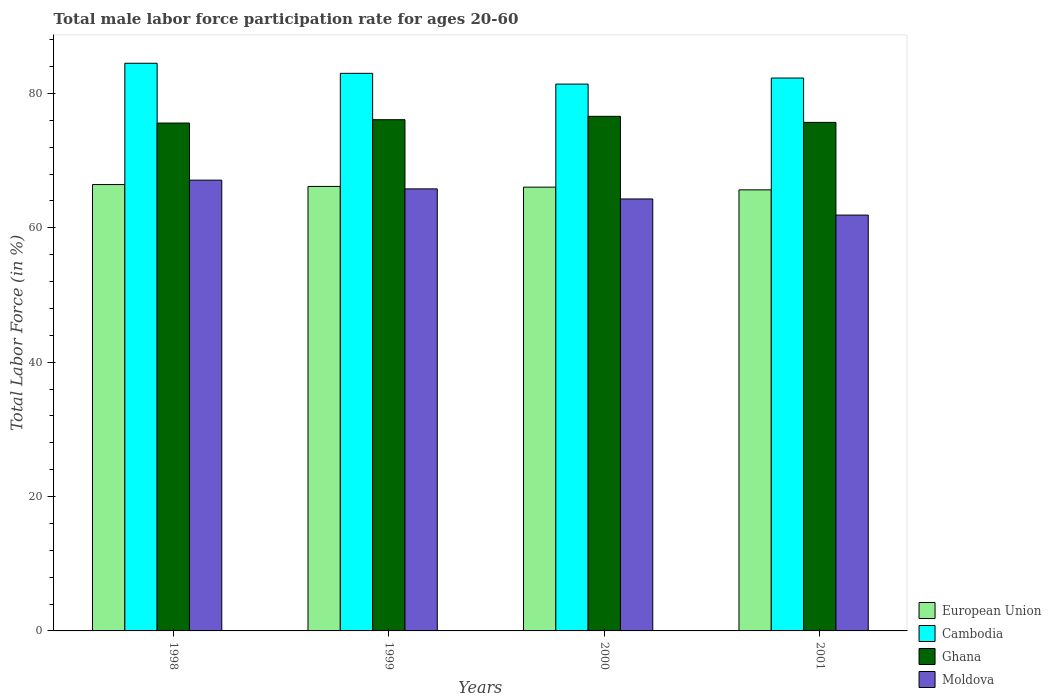How many different coloured bars are there?
Your answer should be compact. 4. Are the number of bars per tick equal to the number of legend labels?
Give a very brief answer. Yes. How many bars are there on the 3rd tick from the left?
Offer a very short reply. 4. How many bars are there on the 1st tick from the right?
Your response must be concise. 4. In how many cases, is the number of bars for a given year not equal to the number of legend labels?
Your answer should be very brief. 0. What is the male labor force participation rate in Moldova in 1998?
Your answer should be compact. 67.1. Across all years, what is the maximum male labor force participation rate in Cambodia?
Offer a very short reply. 84.5. Across all years, what is the minimum male labor force participation rate in Cambodia?
Make the answer very short. 81.4. In which year was the male labor force participation rate in Moldova maximum?
Offer a very short reply. 1998. In which year was the male labor force participation rate in Ghana minimum?
Provide a succinct answer. 1998. What is the total male labor force participation rate in Cambodia in the graph?
Provide a succinct answer. 331.2. What is the difference between the male labor force participation rate in Cambodia in 1998 and that in 2001?
Your response must be concise. 2.2. What is the difference between the male labor force participation rate in Moldova in 2000 and the male labor force participation rate in Ghana in 1998?
Your response must be concise. -11.3. What is the average male labor force participation rate in Cambodia per year?
Make the answer very short. 82.8. In the year 2000, what is the difference between the male labor force participation rate in Moldova and male labor force participation rate in Ghana?
Your answer should be very brief. -12.3. What is the ratio of the male labor force participation rate in Cambodia in 1999 to that in 2000?
Make the answer very short. 1.02. Is the difference between the male labor force participation rate in Moldova in 1998 and 1999 greater than the difference between the male labor force participation rate in Ghana in 1998 and 1999?
Your response must be concise. Yes. What is the difference between the highest and the second highest male labor force participation rate in Cambodia?
Ensure brevity in your answer.  1.5. What is the difference between the highest and the lowest male labor force participation rate in Cambodia?
Make the answer very short. 3.1. In how many years, is the male labor force participation rate in Moldova greater than the average male labor force participation rate in Moldova taken over all years?
Your answer should be compact. 2. What does the 2nd bar from the left in 1999 represents?
Provide a short and direct response. Cambodia. What does the 2nd bar from the right in 1999 represents?
Offer a very short reply. Ghana. Is it the case that in every year, the sum of the male labor force participation rate in European Union and male labor force participation rate in Ghana is greater than the male labor force participation rate in Moldova?
Your response must be concise. Yes. How many bars are there?
Make the answer very short. 16. Are all the bars in the graph horizontal?
Your answer should be very brief. No. How many years are there in the graph?
Your response must be concise. 4. What is the difference between two consecutive major ticks on the Y-axis?
Your answer should be very brief. 20. Does the graph contain grids?
Your answer should be compact. No. Where does the legend appear in the graph?
Your answer should be compact. Bottom right. How many legend labels are there?
Keep it short and to the point. 4. How are the legend labels stacked?
Your answer should be compact. Vertical. What is the title of the graph?
Your response must be concise. Total male labor force participation rate for ages 20-60. Does "Upper middle income" appear as one of the legend labels in the graph?
Your answer should be compact. No. What is the label or title of the Y-axis?
Give a very brief answer. Total Labor Force (in %). What is the Total Labor Force (in %) in European Union in 1998?
Provide a short and direct response. 66.44. What is the Total Labor Force (in %) of Cambodia in 1998?
Your answer should be very brief. 84.5. What is the Total Labor Force (in %) in Ghana in 1998?
Ensure brevity in your answer.  75.6. What is the Total Labor Force (in %) in Moldova in 1998?
Provide a short and direct response. 67.1. What is the Total Labor Force (in %) in European Union in 1999?
Provide a succinct answer. 66.16. What is the Total Labor Force (in %) of Ghana in 1999?
Your answer should be very brief. 76.1. What is the Total Labor Force (in %) of Moldova in 1999?
Offer a very short reply. 65.8. What is the Total Labor Force (in %) of European Union in 2000?
Keep it short and to the point. 66.06. What is the Total Labor Force (in %) in Cambodia in 2000?
Keep it short and to the point. 81.4. What is the Total Labor Force (in %) of Ghana in 2000?
Keep it short and to the point. 76.6. What is the Total Labor Force (in %) in Moldova in 2000?
Your answer should be very brief. 64.3. What is the Total Labor Force (in %) of European Union in 2001?
Your answer should be very brief. 65.66. What is the Total Labor Force (in %) in Cambodia in 2001?
Your response must be concise. 82.3. What is the Total Labor Force (in %) in Ghana in 2001?
Keep it short and to the point. 75.7. What is the Total Labor Force (in %) of Moldova in 2001?
Your answer should be compact. 61.9. Across all years, what is the maximum Total Labor Force (in %) of European Union?
Ensure brevity in your answer.  66.44. Across all years, what is the maximum Total Labor Force (in %) of Cambodia?
Provide a succinct answer. 84.5. Across all years, what is the maximum Total Labor Force (in %) in Ghana?
Provide a succinct answer. 76.6. Across all years, what is the maximum Total Labor Force (in %) of Moldova?
Ensure brevity in your answer.  67.1. Across all years, what is the minimum Total Labor Force (in %) in European Union?
Your response must be concise. 65.66. Across all years, what is the minimum Total Labor Force (in %) in Cambodia?
Offer a terse response. 81.4. Across all years, what is the minimum Total Labor Force (in %) of Ghana?
Ensure brevity in your answer.  75.6. Across all years, what is the minimum Total Labor Force (in %) of Moldova?
Keep it short and to the point. 61.9. What is the total Total Labor Force (in %) of European Union in the graph?
Your answer should be compact. 264.32. What is the total Total Labor Force (in %) of Cambodia in the graph?
Your answer should be compact. 331.2. What is the total Total Labor Force (in %) of Ghana in the graph?
Offer a very short reply. 304. What is the total Total Labor Force (in %) of Moldova in the graph?
Make the answer very short. 259.1. What is the difference between the Total Labor Force (in %) in European Union in 1998 and that in 1999?
Keep it short and to the point. 0.28. What is the difference between the Total Labor Force (in %) of European Union in 1998 and that in 2000?
Your response must be concise. 0.38. What is the difference between the Total Labor Force (in %) of Cambodia in 1998 and that in 2000?
Give a very brief answer. 3.1. What is the difference between the Total Labor Force (in %) in Moldova in 1998 and that in 2000?
Give a very brief answer. 2.8. What is the difference between the Total Labor Force (in %) of European Union in 1998 and that in 2001?
Ensure brevity in your answer.  0.79. What is the difference between the Total Labor Force (in %) of Cambodia in 1998 and that in 2001?
Offer a very short reply. 2.2. What is the difference between the Total Labor Force (in %) of European Union in 1999 and that in 2000?
Your answer should be very brief. 0.1. What is the difference between the Total Labor Force (in %) in Moldova in 1999 and that in 2000?
Your answer should be compact. 1.5. What is the difference between the Total Labor Force (in %) of European Union in 1999 and that in 2001?
Provide a succinct answer. 0.51. What is the difference between the Total Labor Force (in %) in Cambodia in 1999 and that in 2001?
Provide a succinct answer. 0.7. What is the difference between the Total Labor Force (in %) of Ghana in 1999 and that in 2001?
Give a very brief answer. 0.4. What is the difference between the Total Labor Force (in %) of European Union in 2000 and that in 2001?
Keep it short and to the point. 0.41. What is the difference between the Total Labor Force (in %) of Ghana in 2000 and that in 2001?
Offer a terse response. 0.9. What is the difference between the Total Labor Force (in %) in European Union in 1998 and the Total Labor Force (in %) in Cambodia in 1999?
Offer a very short reply. -16.56. What is the difference between the Total Labor Force (in %) of European Union in 1998 and the Total Labor Force (in %) of Ghana in 1999?
Your answer should be very brief. -9.66. What is the difference between the Total Labor Force (in %) of European Union in 1998 and the Total Labor Force (in %) of Moldova in 1999?
Your answer should be compact. 0.64. What is the difference between the Total Labor Force (in %) in Cambodia in 1998 and the Total Labor Force (in %) in Ghana in 1999?
Your response must be concise. 8.4. What is the difference between the Total Labor Force (in %) in Ghana in 1998 and the Total Labor Force (in %) in Moldova in 1999?
Your response must be concise. 9.8. What is the difference between the Total Labor Force (in %) in European Union in 1998 and the Total Labor Force (in %) in Cambodia in 2000?
Offer a terse response. -14.96. What is the difference between the Total Labor Force (in %) in European Union in 1998 and the Total Labor Force (in %) in Ghana in 2000?
Provide a short and direct response. -10.16. What is the difference between the Total Labor Force (in %) in European Union in 1998 and the Total Labor Force (in %) in Moldova in 2000?
Your answer should be very brief. 2.14. What is the difference between the Total Labor Force (in %) of Cambodia in 1998 and the Total Labor Force (in %) of Moldova in 2000?
Your answer should be compact. 20.2. What is the difference between the Total Labor Force (in %) of Ghana in 1998 and the Total Labor Force (in %) of Moldova in 2000?
Your answer should be compact. 11.3. What is the difference between the Total Labor Force (in %) in European Union in 1998 and the Total Labor Force (in %) in Cambodia in 2001?
Give a very brief answer. -15.86. What is the difference between the Total Labor Force (in %) of European Union in 1998 and the Total Labor Force (in %) of Ghana in 2001?
Provide a succinct answer. -9.26. What is the difference between the Total Labor Force (in %) of European Union in 1998 and the Total Labor Force (in %) of Moldova in 2001?
Offer a very short reply. 4.54. What is the difference between the Total Labor Force (in %) of Cambodia in 1998 and the Total Labor Force (in %) of Moldova in 2001?
Provide a short and direct response. 22.6. What is the difference between the Total Labor Force (in %) of European Union in 1999 and the Total Labor Force (in %) of Cambodia in 2000?
Give a very brief answer. -15.24. What is the difference between the Total Labor Force (in %) of European Union in 1999 and the Total Labor Force (in %) of Ghana in 2000?
Your answer should be compact. -10.44. What is the difference between the Total Labor Force (in %) in European Union in 1999 and the Total Labor Force (in %) in Moldova in 2000?
Give a very brief answer. 1.86. What is the difference between the Total Labor Force (in %) of European Union in 1999 and the Total Labor Force (in %) of Cambodia in 2001?
Keep it short and to the point. -16.14. What is the difference between the Total Labor Force (in %) of European Union in 1999 and the Total Labor Force (in %) of Ghana in 2001?
Ensure brevity in your answer.  -9.54. What is the difference between the Total Labor Force (in %) of European Union in 1999 and the Total Labor Force (in %) of Moldova in 2001?
Ensure brevity in your answer.  4.26. What is the difference between the Total Labor Force (in %) of Cambodia in 1999 and the Total Labor Force (in %) of Moldova in 2001?
Provide a short and direct response. 21.1. What is the difference between the Total Labor Force (in %) of Ghana in 1999 and the Total Labor Force (in %) of Moldova in 2001?
Make the answer very short. 14.2. What is the difference between the Total Labor Force (in %) in European Union in 2000 and the Total Labor Force (in %) in Cambodia in 2001?
Offer a very short reply. -16.24. What is the difference between the Total Labor Force (in %) of European Union in 2000 and the Total Labor Force (in %) of Ghana in 2001?
Give a very brief answer. -9.64. What is the difference between the Total Labor Force (in %) of European Union in 2000 and the Total Labor Force (in %) of Moldova in 2001?
Keep it short and to the point. 4.16. What is the difference between the Total Labor Force (in %) of Ghana in 2000 and the Total Labor Force (in %) of Moldova in 2001?
Your response must be concise. 14.7. What is the average Total Labor Force (in %) in European Union per year?
Offer a terse response. 66.08. What is the average Total Labor Force (in %) in Cambodia per year?
Ensure brevity in your answer.  82.8. What is the average Total Labor Force (in %) in Ghana per year?
Ensure brevity in your answer.  76. What is the average Total Labor Force (in %) in Moldova per year?
Provide a succinct answer. 64.78. In the year 1998, what is the difference between the Total Labor Force (in %) in European Union and Total Labor Force (in %) in Cambodia?
Your answer should be compact. -18.06. In the year 1998, what is the difference between the Total Labor Force (in %) of European Union and Total Labor Force (in %) of Ghana?
Ensure brevity in your answer.  -9.16. In the year 1998, what is the difference between the Total Labor Force (in %) of European Union and Total Labor Force (in %) of Moldova?
Provide a succinct answer. -0.66. In the year 1998, what is the difference between the Total Labor Force (in %) in Cambodia and Total Labor Force (in %) in Moldova?
Your answer should be very brief. 17.4. In the year 1998, what is the difference between the Total Labor Force (in %) of Ghana and Total Labor Force (in %) of Moldova?
Your answer should be compact. 8.5. In the year 1999, what is the difference between the Total Labor Force (in %) of European Union and Total Labor Force (in %) of Cambodia?
Offer a terse response. -16.84. In the year 1999, what is the difference between the Total Labor Force (in %) in European Union and Total Labor Force (in %) in Ghana?
Your response must be concise. -9.94. In the year 1999, what is the difference between the Total Labor Force (in %) in European Union and Total Labor Force (in %) in Moldova?
Provide a short and direct response. 0.36. In the year 1999, what is the difference between the Total Labor Force (in %) in Cambodia and Total Labor Force (in %) in Moldova?
Your answer should be very brief. 17.2. In the year 1999, what is the difference between the Total Labor Force (in %) of Ghana and Total Labor Force (in %) of Moldova?
Offer a very short reply. 10.3. In the year 2000, what is the difference between the Total Labor Force (in %) of European Union and Total Labor Force (in %) of Cambodia?
Your response must be concise. -15.34. In the year 2000, what is the difference between the Total Labor Force (in %) of European Union and Total Labor Force (in %) of Ghana?
Keep it short and to the point. -10.54. In the year 2000, what is the difference between the Total Labor Force (in %) in European Union and Total Labor Force (in %) in Moldova?
Your answer should be very brief. 1.76. In the year 2000, what is the difference between the Total Labor Force (in %) of Cambodia and Total Labor Force (in %) of Ghana?
Offer a terse response. 4.8. In the year 2000, what is the difference between the Total Labor Force (in %) of Cambodia and Total Labor Force (in %) of Moldova?
Ensure brevity in your answer.  17.1. In the year 2000, what is the difference between the Total Labor Force (in %) in Ghana and Total Labor Force (in %) in Moldova?
Provide a succinct answer. 12.3. In the year 2001, what is the difference between the Total Labor Force (in %) in European Union and Total Labor Force (in %) in Cambodia?
Provide a succinct answer. -16.64. In the year 2001, what is the difference between the Total Labor Force (in %) in European Union and Total Labor Force (in %) in Ghana?
Offer a very short reply. -10.04. In the year 2001, what is the difference between the Total Labor Force (in %) of European Union and Total Labor Force (in %) of Moldova?
Offer a very short reply. 3.76. In the year 2001, what is the difference between the Total Labor Force (in %) in Cambodia and Total Labor Force (in %) in Ghana?
Ensure brevity in your answer.  6.6. In the year 2001, what is the difference between the Total Labor Force (in %) of Cambodia and Total Labor Force (in %) of Moldova?
Provide a succinct answer. 20.4. What is the ratio of the Total Labor Force (in %) of European Union in 1998 to that in 1999?
Keep it short and to the point. 1. What is the ratio of the Total Labor Force (in %) of Cambodia in 1998 to that in 1999?
Provide a short and direct response. 1.02. What is the ratio of the Total Labor Force (in %) in Moldova in 1998 to that in 1999?
Provide a succinct answer. 1.02. What is the ratio of the Total Labor Force (in %) in Cambodia in 1998 to that in 2000?
Offer a very short reply. 1.04. What is the ratio of the Total Labor Force (in %) in Ghana in 1998 to that in 2000?
Your answer should be compact. 0.99. What is the ratio of the Total Labor Force (in %) in Moldova in 1998 to that in 2000?
Your answer should be compact. 1.04. What is the ratio of the Total Labor Force (in %) in European Union in 1998 to that in 2001?
Give a very brief answer. 1.01. What is the ratio of the Total Labor Force (in %) of Cambodia in 1998 to that in 2001?
Your response must be concise. 1.03. What is the ratio of the Total Labor Force (in %) of Moldova in 1998 to that in 2001?
Your response must be concise. 1.08. What is the ratio of the Total Labor Force (in %) in Cambodia in 1999 to that in 2000?
Offer a terse response. 1.02. What is the ratio of the Total Labor Force (in %) of Ghana in 1999 to that in 2000?
Make the answer very short. 0.99. What is the ratio of the Total Labor Force (in %) in Moldova in 1999 to that in 2000?
Your response must be concise. 1.02. What is the ratio of the Total Labor Force (in %) in Cambodia in 1999 to that in 2001?
Make the answer very short. 1.01. What is the ratio of the Total Labor Force (in %) of Moldova in 1999 to that in 2001?
Your response must be concise. 1.06. What is the ratio of the Total Labor Force (in %) in European Union in 2000 to that in 2001?
Offer a terse response. 1.01. What is the ratio of the Total Labor Force (in %) in Cambodia in 2000 to that in 2001?
Keep it short and to the point. 0.99. What is the ratio of the Total Labor Force (in %) in Ghana in 2000 to that in 2001?
Your response must be concise. 1.01. What is the ratio of the Total Labor Force (in %) of Moldova in 2000 to that in 2001?
Provide a succinct answer. 1.04. What is the difference between the highest and the second highest Total Labor Force (in %) of European Union?
Make the answer very short. 0.28. What is the difference between the highest and the second highest Total Labor Force (in %) in Cambodia?
Your answer should be very brief. 1.5. What is the difference between the highest and the second highest Total Labor Force (in %) of Ghana?
Your answer should be very brief. 0.5. What is the difference between the highest and the lowest Total Labor Force (in %) of European Union?
Provide a short and direct response. 0.79. What is the difference between the highest and the lowest Total Labor Force (in %) in Cambodia?
Give a very brief answer. 3.1. What is the difference between the highest and the lowest Total Labor Force (in %) in Ghana?
Offer a terse response. 1. What is the difference between the highest and the lowest Total Labor Force (in %) of Moldova?
Provide a succinct answer. 5.2. 